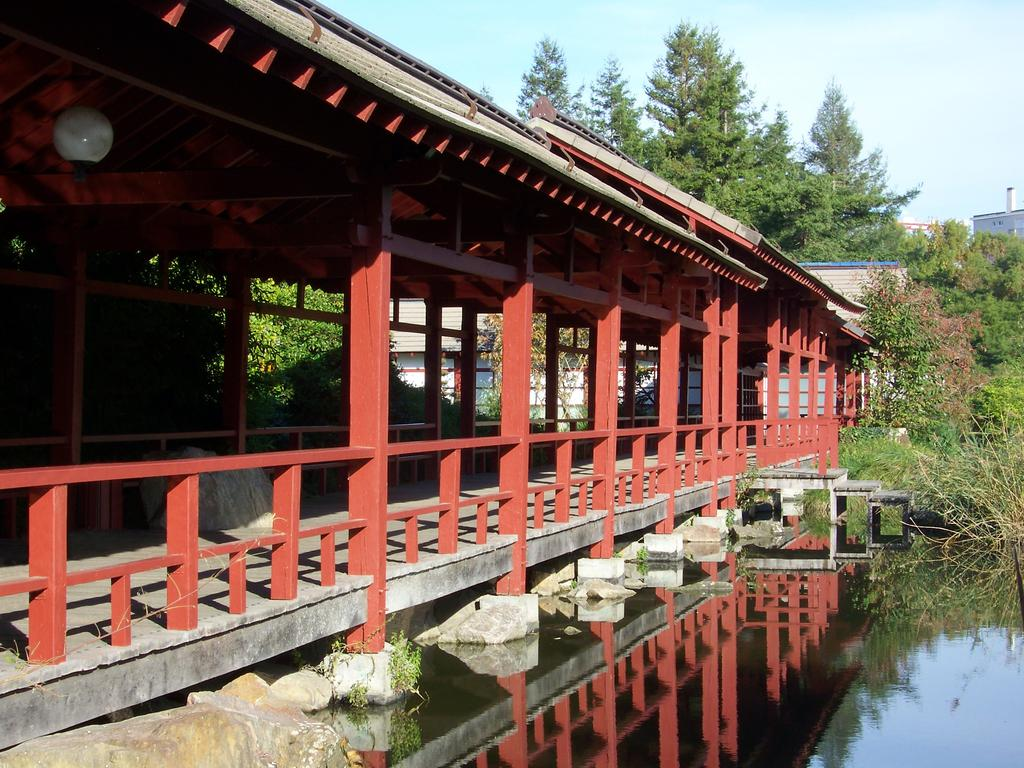What type of structures can be seen in the image? There are buildings and a shed in the image. What type of enclosure is present in the image? There is fencing in the image. What type of vegetation is present in the image? There are trees in the image. What type of natural feature can be seen in the image? There is water visible in the image. What type of material is present in the image? There are stones in the image. What is the color of the sky in the image? The sky is blue in color. What type of music can be heard playing in the image? There is no music present in the image. Can you see a giraffe in the image? There is no giraffe present in the image. 